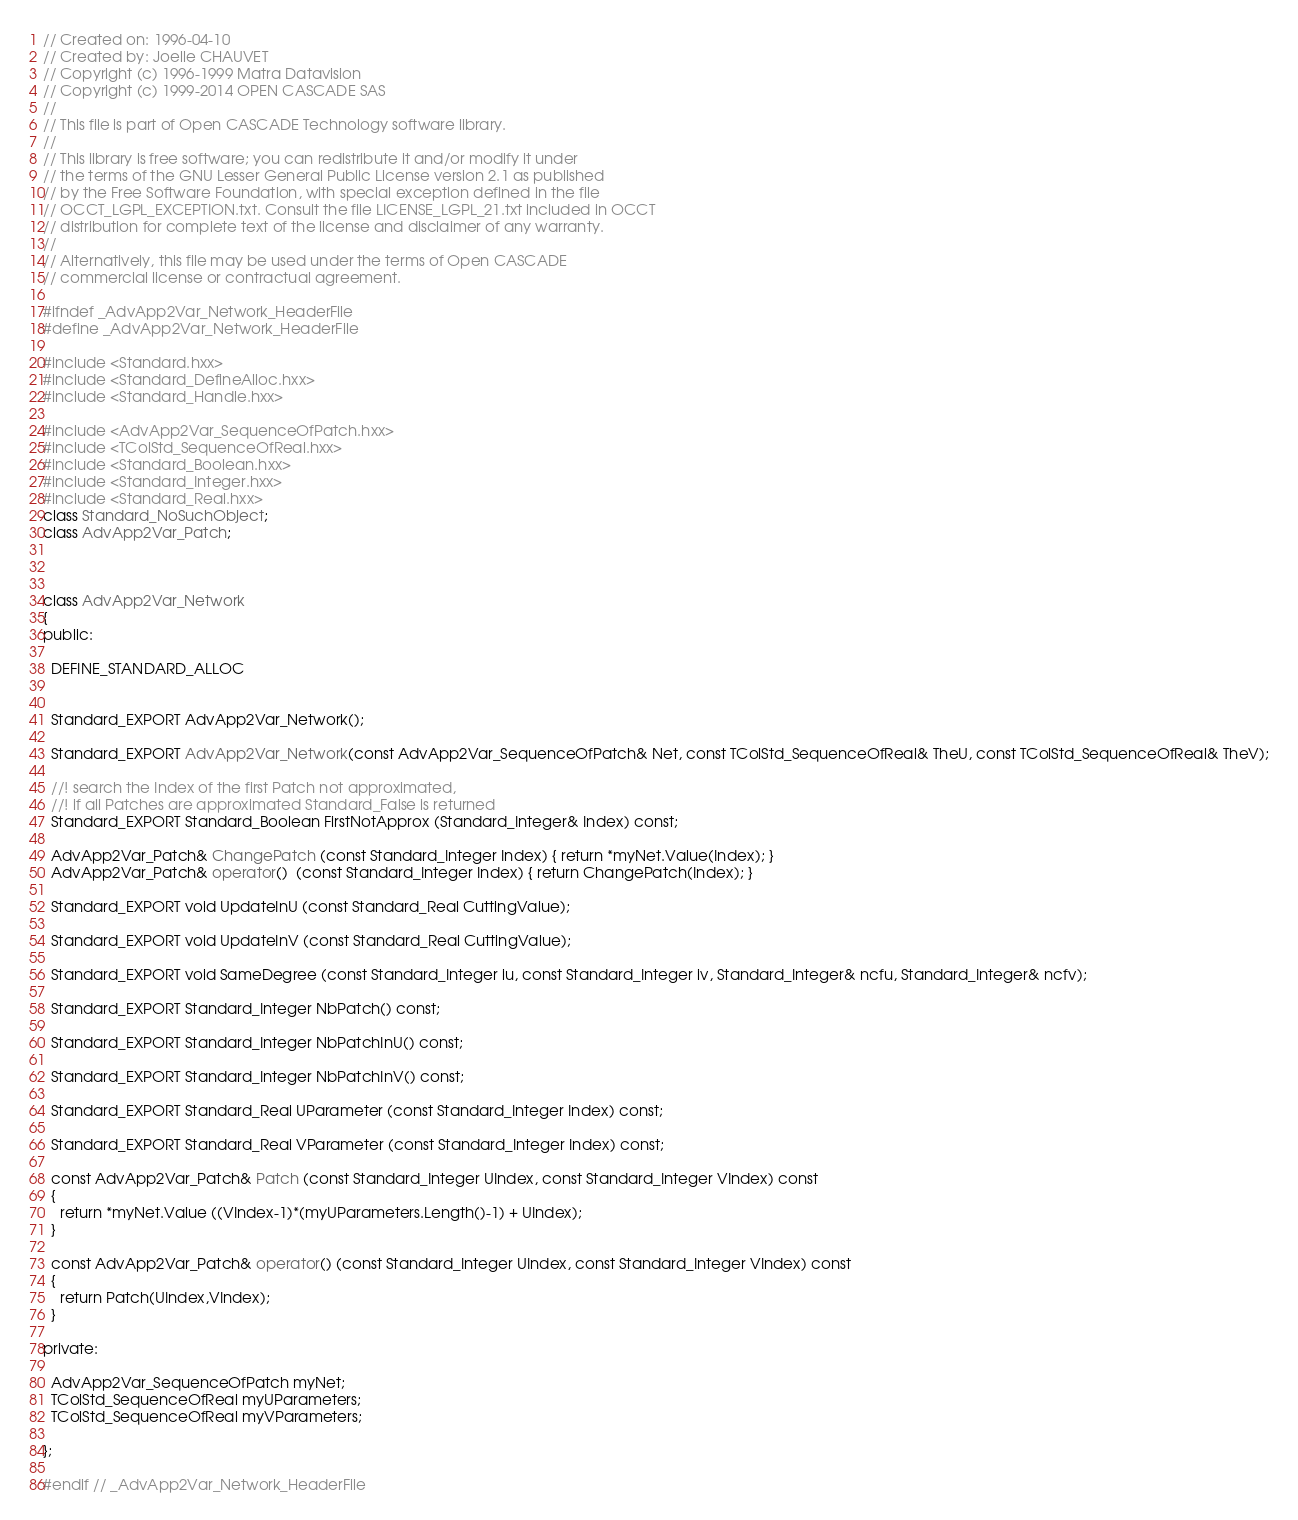Convert code to text. <code><loc_0><loc_0><loc_500><loc_500><_C++_>// Created on: 1996-04-10
// Created by: Joelle CHAUVET
// Copyright (c) 1996-1999 Matra Datavision
// Copyright (c) 1999-2014 OPEN CASCADE SAS
//
// This file is part of Open CASCADE Technology software library.
//
// This library is free software; you can redistribute it and/or modify it under
// the terms of the GNU Lesser General Public License version 2.1 as published
// by the Free Software Foundation, with special exception defined in the file
// OCCT_LGPL_EXCEPTION.txt. Consult the file LICENSE_LGPL_21.txt included in OCCT
// distribution for complete text of the license and disclaimer of any warranty.
//
// Alternatively, this file may be used under the terms of Open CASCADE
// commercial license or contractual agreement.

#ifndef _AdvApp2Var_Network_HeaderFile
#define _AdvApp2Var_Network_HeaderFile

#include <Standard.hxx>
#include <Standard_DefineAlloc.hxx>
#include <Standard_Handle.hxx>

#include <AdvApp2Var_SequenceOfPatch.hxx>
#include <TColStd_SequenceOfReal.hxx>
#include <Standard_Boolean.hxx>
#include <Standard_Integer.hxx>
#include <Standard_Real.hxx>
class Standard_NoSuchObject;
class AdvApp2Var_Patch;



class AdvApp2Var_Network 
{
public:

  DEFINE_STANDARD_ALLOC

  
  Standard_EXPORT AdvApp2Var_Network();
  
  Standard_EXPORT AdvApp2Var_Network(const AdvApp2Var_SequenceOfPatch& Net, const TColStd_SequenceOfReal& TheU, const TColStd_SequenceOfReal& TheV);
  
  //! search the Index of the first Patch not approximated,
  //! if all Patches are approximated Standard_False is returned
  Standard_EXPORT Standard_Boolean FirstNotApprox (Standard_Integer& Index) const;
  
  AdvApp2Var_Patch& ChangePatch (const Standard_Integer Index) { return *myNet.Value(Index); }
  AdvApp2Var_Patch& operator()  (const Standard_Integer Index) { return ChangePatch(Index); }
  
  Standard_EXPORT void UpdateInU (const Standard_Real CuttingValue);
  
  Standard_EXPORT void UpdateInV (const Standard_Real CuttingValue);
  
  Standard_EXPORT void SameDegree (const Standard_Integer iu, const Standard_Integer iv, Standard_Integer& ncfu, Standard_Integer& ncfv);
  
  Standard_EXPORT Standard_Integer NbPatch() const;
  
  Standard_EXPORT Standard_Integer NbPatchInU() const;
  
  Standard_EXPORT Standard_Integer NbPatchInV() const;
  
  Standard_EXPORT Standard_Real UParameter (const Standard_Integer Index) const;
  
  Standard_EXPORT Standard_Real VParameter (const Standard_Integer Index) const;

  const AdvApp2Var_Patch& Patch (const Standard_Integer UIndex, const Standard_Integer VIndex) const
  {
    return *myNet.Value ((VIndex-1)*(myUParameters.Length()-1) + UIndex);
  }

  const AdvApp2Var_Patch& operator() (const Standard_Integer UIndex, const Standard_Integer VIndex) const
  {
    return Patch(UIndex,VIndex);
  }

private:

  AdvApp2Var_SequenceOfPatch myNet;
  TColStd_SequenceOfReal myUParameters;
  TColStd_SequenceOfReal myVParameters;

};

#endif // _AdvApp2Var_Network_HeaderFile
</code> 